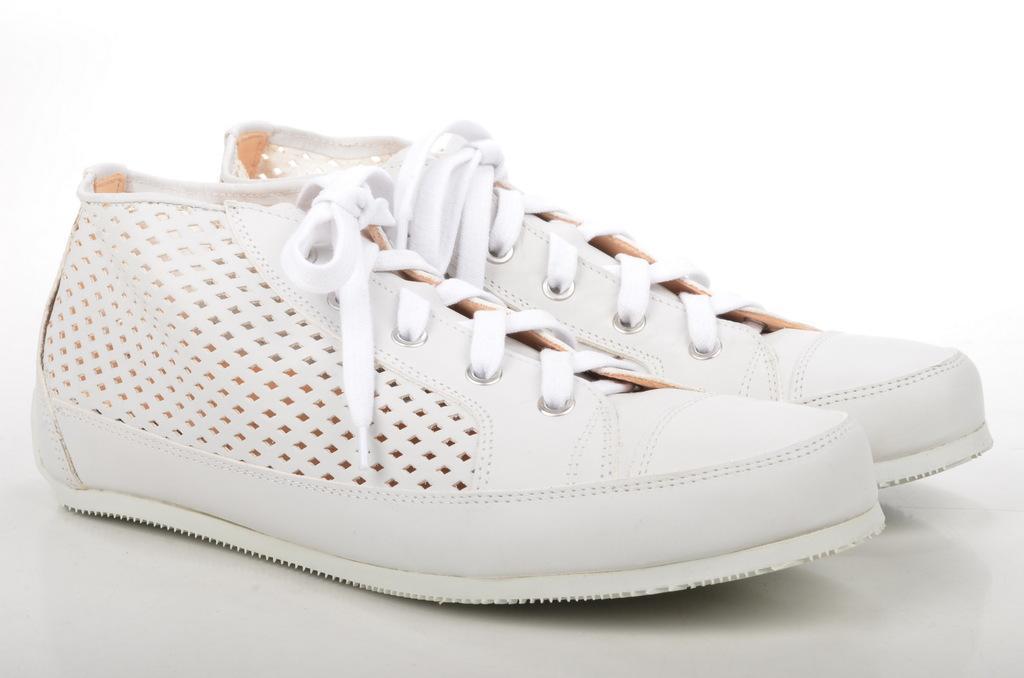In one or two sentences, can you explain what this image depicts? In this picture I can see a pair of shoes, which are of white and cream color and I see that it is on the white color surface. I can also see that it is white color in the background. 